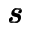<formula> <loc_0><loc_0><loc_500><loc_500>\pm b { s }</formula> 